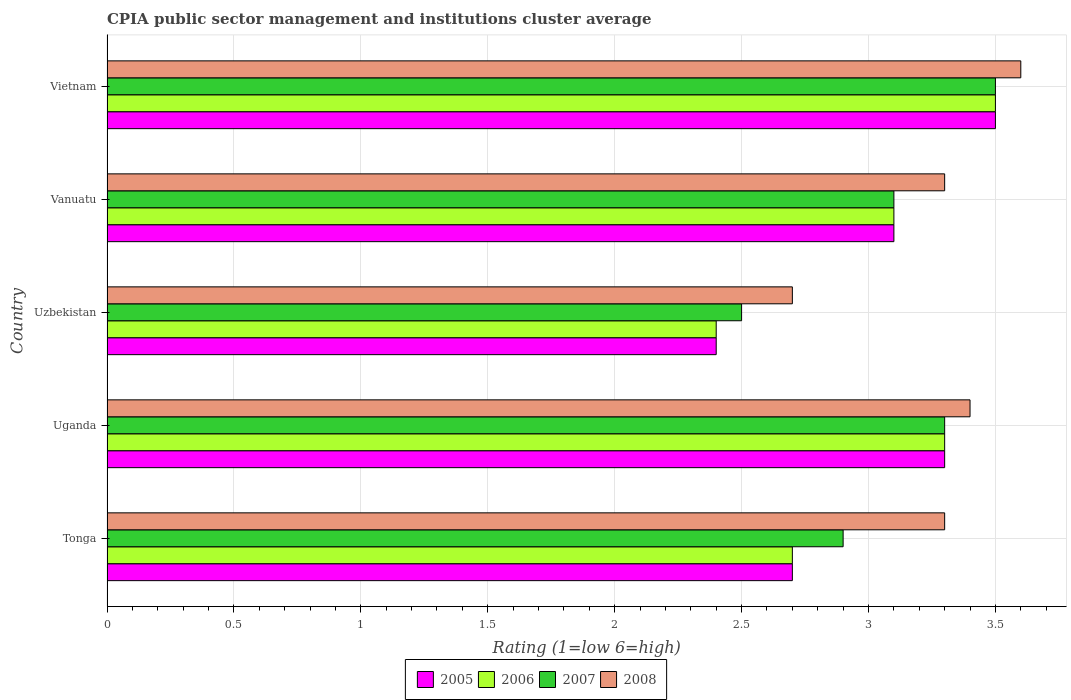How many groups of bars are there?
Your answer should be compact. 5. Are the number of bars on each tick of the Y-axis equal?
Your answer should be very brief. Yes. What is the label of the 4th group of bars from the top?
Your answer should be compact. Uganda. Across all countries, what is the minimum CPIA rating in 2007?
Keep it short and to the point. 2.5. In which country was the CPIA rating in 2007 maximum?
Provide a succinct answer. Vietnam. In which country was the CPIA rating in 2007 minimum?
Ensure brevity in your answer.  Uzbekistan. What is the difference between the CPIA rating in 2005 in Uganda and that in Vanuatu?
Provide a short and direct response. 0.2. What is the difference between the CPIA rating in 2005 in Tonga and the CPIA rating in 2007 in Uganda?
Ensure brevity in your answer.  -0.6. What is the average CPIA rating in 2008 per country?
Provide a succinct answer. 3.26. What is the difference between the CPIA rating in 2006 and CPIA rating in 2008 in Vanuatu?
Offer a terse response. -0.2. In how many countries, is the CPIA rating in 2006 greater than 1.3 ?
Ensure brevity in your answer.  5. What is the ratio of the CPIA rating in 2006 in Uzbekistan to that in Vietnam?
Your answer should be compact. 0.69. Is the CPIA rating in 2008 in Vanuatu less than that in Vietnam?
Provide a short and direct response. Yes. What is the difference between the highest and the second highest CPIA rating in 2006?
Your response must be concise. 0.2. What is the difference between the highest and the lowest CPIA rating in 2007?
Offer a very short reply. 1. Is it the case that in every country, the sum of the CPIA rating in 2005 and CPIA rating in 2008 is greater than the sum of CPIA rating in 2006 and CPIA rating in 2007?
Give a very brief answer. No. Is it the case that in every country, the sum of the CPIA rating in 2008 and CPIA rating in 2007 is greater than the CPIA rating in 2006?
Make the answer very short. Yes. Are all the bars in the graph horizontal?
Your answer should be very brief. Yes. Are the values on the major ticks of X-axis written in scientific E-notation?
Give a very brief answer. No. Does the graph contain any zero values?
Offer a terse response. No. Does the graph contain grids?
Offer a terse response. Yes. Where does the legend appear in the graph?
Make the answer very short. Bottom center. What is the title of the graph?
Provide a succinct answer. CPIA public sector management and institutions cluster average. What is the label or title of the Y-axis?
Offer a terse response. Country. What is the Rating (1=low 6=high) in 2006 in Tonga?
Your answer should be very brief. 2.7. What is the Rating (1=low 6=high) of 2007 in Tonga?
Ensure brevity in your answer.  2.9. What is the Rating (1=low 6=high) of 2008 in Tonga?
Provide a succinct answer. 3.3. What is the Rating (1=low 6=high) in 2005 in Uganda?
Your answer should be compact. 3.3. What is the Rating (1=low 6=high) of 2006 in Uganda?
Offer a terse response. 3.3. What is the Rating (1=low 6=high) in 2005 in Uzbekistan?
Keep it short and to the point. 2.4. What is the Rating (1=low 6=high) in 2006 in Uzbekistan?
Provide a short and direct response. 2.4. What is the Rating (1=low 6=high) in 2007 in Uzbekistan?
Make the answer very short. 2.5. What is the Rating (1=low 6=high) of 2008 in Uzbekistan?
Provide a short and direct response. 2.7. What is the Rating (1=low 6=high) of 2005 in Vanuatu?
Keep it short and to the point. 3.1. What is the Rating (1=low 6=high) of 2007 in Vanuatu?
Your response must be concise. 3.1. What is the Rating (1=low 6=high) of 2007 in Vietnam?
Provide a short and direct response. 3.5. What is the Rating (1=low 6=high) in 2008 in Vietnam?
Your answer should be very brief. 3.6. Across all countries, what is the maximum Rating (1=low 6=high) of 2005?
Keep it short and to the point. 3.5. Across all countries, what is the maximum Rating (1=low 6=high) in 2007?
Your answer should be very brief. 3.5. Across all countries, what is the maximum Rating (1=low 6=high) of 2008?
Your response must be concise. 3.6. What is the total Rating (1=low 6=high) in 2007 in the graph?
Give a very brief answer. 15.3. What is the difference between the Rating (1=low 6=high) in 2007 in Tonga and that in Uganda?
Your answer should be compact. -0.4. What is the difference between the Rating (1=low 6=high) in 2005 in Tonga and that in Uzbekistan?
Provide a succinct answer. 0.3. What is the difference between the Rating (1=low 6=high) of 2006 in Tonga and that in Uzbekistan?
Make the answer very short. 0.3. What is the difference between the Rating (1=low 6=high) of 2007 in Tonga and that in Uzbekistan?
Offer a terse response. 0.4. What is the difference between the Rating (1=low 6=high) of 2008 in Tonga and that in Uzbekistan?
Provide a short and direct response. 0.6. What is the difference between the Rating (1=low 6=high) of 2005 in Tonga and that in Vanuatu?
Your response must be concise. -0.4. What is the difference between the Rating (1=low 6=high) of 2006 in Tonga and that in Vanuatu?
Your response must be concise. -0.4. What is the difference between the Rating (1=low 6=high) in 2007 in Tonga and that in Vanuatu?
Keep it short and to the point. -0.2. What is the difference between the Rating (1=low 6=high) in 2008 in Tonga and that in Vanuatu?
Offer a very short reply. 0. What is the difference between the Rating (1=low 6=high) in 2005 in Tonga and that in Vietnam?
Your answer should be compact. -0.8. What is the difference between the Rating (1=low 6=high) of 2006 in Tonga and that in Vietnam?
Provide a succinct answer. -0.8. What is the difference between the Rating (1=low 6=high) in 2007 in Tonga and that in Vietnam?
Make the answer very short. -0.6. What is the difference between the Rating (1=low 6=high) in 2008 in Tonga and that in Vietnam?
Offer a very short reply. -0.3. What is the difference between the Rating (1=low 6=high) in 2005 in Uganda and that in Uzbekistan?
Give a very brief answer. 0.9. What is the difference between the Rating (1=low 6=high) of 2006 in Uganda and that in Uzbekistan?
Your response must be concise. 0.9. What is the difference between the Rating (1=low 6=high) of 2007 in Uganda and that in Uzbekistan?
Provide a succinct answer. 0.8. What is the difference between the Rating (1=low 6=high) in 2006 in Uganda and that in Vanuatu?
Ensure brevity in your answer.  0.2. What is the difference between the Rating (1=low 6=high) in 2006 in Uganda and that in Vietnam?
Keep it short and to the point. -0.2. What is the difference between the Rating (1=low 6=high) in 2007 in Uganda and that in Vietnam?
Ensure brevity in your answer.  -0.2. What is the difference between the Rating (1=low 6=high) in 2006 in Uzbekistan and that in Vanuatu?
Your response must be concise. -0.7. What is the difference between the Rating (1=low 6=high) of 2008 in Uzbekistan and that in Vanuatu?
Give a very brief answer. -0.6. What is the difference between the Rating (1=low 6=high) of 2006 in Uzbekistan and that in Vietnam?
Provide a short and direct response. -1.1. What is the difference between the Rating (1=low 6=high) of 2006 in Vanuatu and that in Vietnam?
Provide a short and direct response. -0.4. What is the difference between the Rating (1=low 6=high) in 2007 in Vanuatu and that in Vietnam?
Your answer should be very brief. -0.4. What is the difference between the Rating (1=low 6=high) in 2005 in Tonga and the Rating (1=low 6=high) in 2007 in Uganda?
Your response must be concise. -0.6. What is the difference between the Rating (1=low 6=high) of 2005 in Tonga and the Rating (1=low 6=high) of 2008 in Uganda?
Make the answer very short. -0.7. What is the difference between the Rating (1=low 6=high) of 2005 in Tonga and the Rating (1=low 6=high) of 2008 in Uzbekistan?
Offer a terse response. 0. What is the difference between the Rating (1=low 6=high) in 2006 in Tonga and the Rating (1=low 6=high) in 2008 in Uzbekistan?
Give a very brief answer. 0. What is the difference between the Rating (1=low 6=high) in 2007 in Tonga and the Rating (1=low 6=high) in 2008 in Uzbekistan?
Your answer should be compact. 0.2. What is the difference between the Rating (1=low 6=high) of 2005 in Tonga and the Rating (1=low 6=high) of 2008 in Vanuatu?
Your answer should be compact. -0.6. What is the difference between the Rating (1=low 6=high) of 2006 in Tonga and the Rating (1=low 6=high) of 2007 in Vanuatu?
Offer a very short reply. -0.4. What is the difference between the Rating (1=low 6=high) in 2006 in Tonga and the Rating (1=low 6=high) in 2008 in Vanuatu?
Your answer should be very brief. -0.6. What is the difference between the Rating (1=low 6=high) of 2005 in Tonga and the Rating (1=low 6=high) of 2006 in Vietnam?
Offer a very short reply. -0.8. What is the difference between the Rating (1=low 6=high) in 2006 in Tonga and the Rating (1=low 6=high) in 2008 in Vietnam?
Your answer should be compact. -0.9. What is the difference between the Rating (1=low 6=high) of 2005 in Uganda and the Rating (1=low 6=high) of 2007 in Uzbekistan?
Offer a very short reply. 0.8. What is the difference between the Rating (1=low 6=high) of 2006 in Uganda and the Rating (1=low 6=high) of 2007 in Uzbekistan?
Your answer should be very brief. 0.8. What is the difference between the Rating (1=low 6=high) of 2006 in Uganda and the Rating (1=low 6=high) of 2008 in Uzbekistan?
Offer a terse response. 0.6. What is the difference between the Rating (1=low 6=high) in 2005 in Uganda and the Rating (1=low 6=high) in 2006 in Vanuatu?
Your answer should be very brief. 0.2. What is the difference between the Rating (1=low 6=high) in 2005 in Uganda and the Rating (1=low 6=high) in 2007 in Vanuatu?
Keep it short and to the point. 0.2. What is the difference between the Rating (1=low 6=high) in 2006 in Uganda and the Rating (1=low 6=high) in 2007 in Vanuatu?
Your answer should be compact. 0.2. What is the difference between the Rating (1=low 6=high) in 2007 in Uganda and the Rating (1=low 6=high) in 2008 in Vanuatu?
Your response must be concise. 0. What is the difference between the Rating (1=low 6=high) in 2005 in Uganda and the Rating (1=low 6=high) in 2006 in Vietnam?
Provide a short and direct response. -0.2. What is the difference between the Rating (1=low 6=high) in 2005 in Uganda and the Rating (1=low 6=high) in 2007 in Vietnam?
Ensure brevity in your answer.  -0.2. What is the difference between the Rating (1=low 6=high) of 2005 in Uganda and the Rating (1=low 6=high) of 2008 in Vietnam?
Provide a succinct answer. -0.3. What is the difference between the Rating (1=low 6=high) of 2005 in Uzbekistan and the Rating (1=low 6=high) of 2007 in Vanuatu?
Ensure brevity in your answer.  -0.7. What is the difference between the Rating (1=low 6=high) of 2005 in Uzbekistan and the Rating (1=low 6=high) of 2006 in Vietnam?
Your answer should be compact. -1.1. What is the difference between the Rating (1=low 6=high) of 2007 in Uzbekistan and the Rating (1=low 6=high) of 2008 in Vietnam?
Provide a short and direct response. -1.1. What is the difference between the Rating (1=low 6=high) in 2005 in Vanuatu and the Rating (1=low 6=high) in 2007 in Vietnam?
Give a very brief answer. -0.4. What is the difference between the Rating (1=low 6=high) of 2005 in Vanuatu and the Rating (1=low 6=high) of 2008 in Vietnam?
Your response must be concise. -0.5. What is the difference between the Rating (1=low 6=high) in 2006 in Vanuatu and the Rating (1=low 6=high) in 2008 in Vietnam?
Your answer should be compact. -0.5. What is the difference between the Rating (1=low 6=high) of 2007 in Vanuatu and the Rating (1=low 6=high) of 2008 in Vietnam?
Your answer should be very brief. -0.5. What is the average Rating (1=low 6=high) in 2005 per country?
Your answer should be very brief. 3. What is the average Rating (1=low 6=high) in 2006 per country?
Your answer should be very brief. 3. What is the average Rating (1=low 6=high) of 2007 per country?
Keep it short and to the point. 3.06. What is the average Rating (1=low 6=high) of 2008 per country?
Offer a terse response. 3.26. What is the difference between the Rating (1=low 6=high) in 2005 and Rating (1=low 6=high) in 2007 in Tonga?
Your answer should be very brief. -0.2. What is the difference between the Rating (1=low 6=high) of 2005 and Rating (1=low 6=high) of 2008 in Tonga?
Provide a short and direct response. -0.6. What is the difference between the Rating (1=low 6=high) in 2006 and Rating (1=low 6=high) in 2008 in Tonga?
Keep it short and to the point. -0.6. What is the difference between the Rating (1=low 6=high) of 2007 and Rating (1=low 6=high) of 2008 in Uganda?
Provide a succinct answer. -0.1. What is the difference between the Rating (1=low 6=high) of 2005 and Rating (1=low 6=high) of 2006 in Uzbekistan?
Provide a short and direct response. 0. What is the difference between the Rating (1=low 6=high) of 2005 and Rating (1=low 6=high) of 2007 in Uzbekistan?
Offer a very short reply. -0.1. What is the difference between the Rating (1=low 6=high) in 2005 and Rating (1=low 6=high) in 2008 in Uzbekistan?
Provide a succinct answer. -0.3. What is the difference between the Rating (1=low 6=high) of 2006 and Rating (1=low 6=high) of 2008 in Uzbekistan?
Keep it short and to the point. -0.3. What is the difference between the Rating (1=low 6=high) in 2007 and Rating (1=low 6=high) in 2008 in Uzbekistan?
Offer a terse response. -0.2. What is the difference between the Rating (1=low 6=high) of 2005 and Rating (1=low 6=high) of 2006 in Vanuatu?
Make the answer very short. 0. What is the difference between the Rating (1=low 6=high) in 2005 and Rating (1=low 6=high) in 2008 in Vanuatu?
Make the answer very short. -0.2. What is the difference between the Rating (1=low 6=high) of 2006 and Rating (1=low 6=high) of 2007 in Vanuatu?
Give a very brief answer. 0. What is the difference between the Rating (1=low 6=high) of 2005 and Rating (1=low 6=high) of 2007 in Vietnam?
Keep it short and to the point. 0. What is the difference between the Rating (1=low 6=high) of 2006 and Rating (1=low 6=high) of 2008 in Vietnam?
Ensure brevity in your answer.  -0.1. What is the difference between the Rating (1=low 6=high) of 2007 and Rating (1=low 6=high) of 2008 in Vietnam?
Your answer should be very brief. -0.1. What is the ratio of the Rating (1=low 6=high) of 2005 in Tonga to that in Uganda?
Keep it short and to the point. 0.82. What is the ratio of the Rating (1=low 6=high) in 2006 in Tonga to that in Uganda?
Provide a succinct answer. 0.82. What is the ratio of the Rating (1=low 6=high) in 2007 in Tonga to that in Uganda?
Offer a terse response. 0.88. What is the ratio of the Rating (1=low 6=high) of 2008 in Tonga to that in Uganda?
Your response must be concise. 0.97. What is the ratio of the Rating (1=low 6=high) in 2005 in Tonga to that in Uzbekistan?
Ensure brevity in your answer.  1.12. What is the ratio of the Rating (1=low 6=high) in 2006 in Tonga to that in Uzbekistan?
Provide a short and direct response. 1.12. What is the ratio of the Rating (1=low 6=high) in 2007 in Tonga to that in Uzbekistan?
Your answer should be compact. 1.16. What is the ratio of the Rating (1=low 6=high) of 2008 in Tonga to that in Uzbekistan?
Ensure brevity in your answer.  1.22. What is the ratio of the Rating (1=low 6=high) in 2005 in Tonga to that in Vanuatu?
Make the answer very short. 0.87. What is the ratio of the Rating (1=low 6=high) of 2006 in Tonga to that in Vanuatu?
Keep it short and to the point. 0.87. What is the ratio of the Rating (1=low 6=high) in 2007 in Tonga to that in Vanuatu?
Your answer should be compact. 0.94. What is the ratio of the Rating (1=low 6=high) of 2005 in Tonga to that in Vietnam?
Your answer should be very brief. 0.77. What is the ratio of the Rating (1=low 6=high) in 2006 in Tonga to that in Vietnam?
Keep it short and to the point. 0.77. What is the ratio of the Rating (1=low 6=high) in 2007 in Tonga to that in Vietnam?
Provide a short and direct response. 0.83. What is the ratio of the Rating (1=low 6=high) of 2008 in Tonga to that in Vietnam?
Give a very brief answer. 0.92. What is the ratio of the Rating (1=low 6=high) in 2005 in Uganda to that in Uzbekistan?
Ensure brevity in your answer.  1.38. What is the ratio of the Rating (1=low 6=high) of 2006 in Uganda to that in Uzbekistan?
Provide a succinct answer. 1.38. What is the ratio of the Rating (1=low 6=high) of 2007 in Uganda to that in Uzbekistan?
Keep it short and to the point. 1.32. What is the ratio of the Rating (1=low 6=high) in 2008 in Uganda to that in Uzbekistan?
Provide a short and direct response. 1.26. What is the ratio of the Rating (1=low 6=high) in 2005 in Uganda to that in Vanuatu?
Your answer should be compact. 1.06. What is the ratio of the Rating (1=low 6=high) in 2006 in Uganda to that in Vanuatu?
Provide a short and direct response. 1.06. What is the ratio of the Rating (1=low 6=high) of 2007 in Uganda to that in Vanuatu?
Your answer should be very brief. 1.06. What is the ratio of the Rating (1=low 6=high) of 2008 in Uganda to that in Vanuatu?
Make the answer very short. 1.03. What is the ratio of the Rating (1=low 6=high) of 2005 in Uganda to that in Vietnam?
Provide a succinct answer. 0.94. What is the ratio of the Rating (1=low 6=high) in 2006 in Uganda to that in Vietnam?
Provide a succinct answer. 0.94. What is the ratio of the Rating (1=low 6=high) in 2007 in Uganda to that in Vietnam?
Make the answer very short. 0.94. What is the ratio of the Rating (1=low 6=high) in 2005 in Uzbekistan to that in Vanuatu?
Offer a very short reply. 0.77. What is the ratio of the Rating (1=low 6=high) of 2006 in Uzbekistan to that in Vanuatu?
Your answer should be compact. 0.77. What is the ratio of the Rating (1=low 6=high) of 2007 in Uzbekistan to that in Vanuatu?
Keep it short and to the point. 0.81. What is the ratio of the Rating (1=low 6=high) in 2008 in Uzbekistan to that in Vanuatu?
Offer a very short reply. 0.82. What is the ratio of the Rating (1=low 6=high) in 2005 in Uzbekistan to that in Vietnam?
Keep it short and to the point. 0.69. What is the ratio of the Rating (1=low 6=high) in 2006 in Uzbekistan to that in Vietnam?
Provide a short and direct response. 0.69. What is the ratio of the Rating (1=low 6=high) in 2007 in Uzbekistan to that in Vietnam?
Make the answer very short. 0.71. What is the ratio of the Rating (1=low 6=high) of 2005 in Vanuatu to that in Vietnam?
Your response must be concise. 0.89. What is the ratio of the Rating (1=low 6=high) in 2006 in Vanuatu to that in Vietnam?
Offer a very short reply. 0.89. What is the ratio of the Rating (1=low 6=high) in 2007 in Vanuatu to that in Vietnam?
Ensure brevity in your answer.  0.89. What is the difference between the highest and the second highest Rating (1=low 6=high) in 2005?
Give a very brief answer. 0.2. What is the difference between the highest and the second highest Rating (1=low 6=high) in 2006?
Your answer should be compact. 0.2. What is the difference between the highest and the lowest Rating (1=low 6=high) of 2005?
Provide a short and direct response. 1.1. What is the difference between the highest and the lowest Rating (1=low 6=high) of 2006?
Your response must be concise. 1.1. 